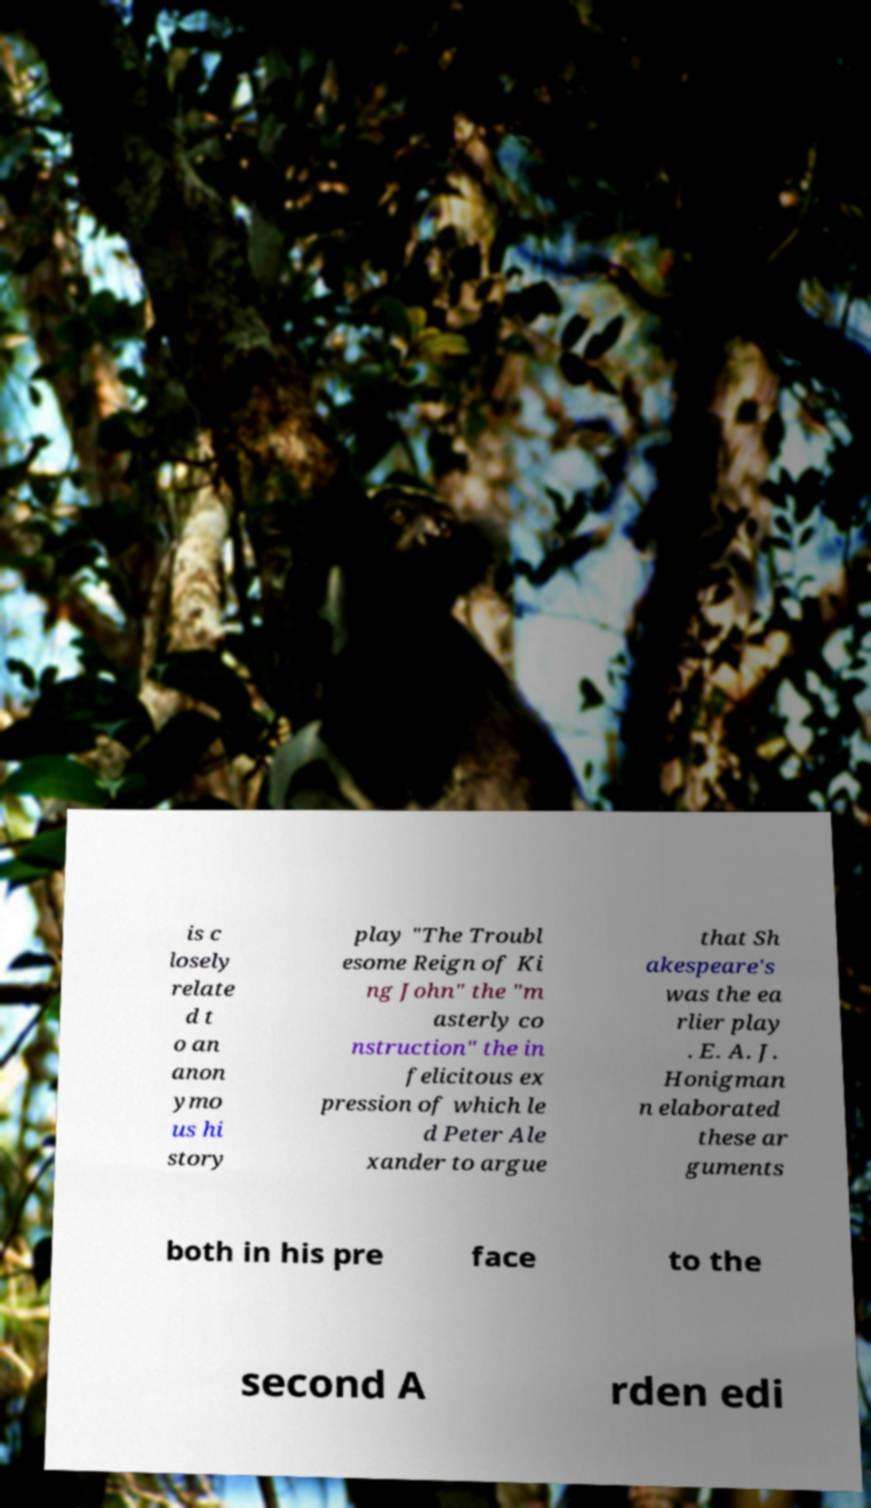Could you assist in decoding the text presented in this image and type it out clearly? is c losely relate d t o an anon ymo us hi story play "The Troubl esome Reign of Ki ng John" the "m asterly co nstruction" the in felicitous ex pression of which le d Peter Ale xander to argue that Sh akespeare's was the ea rlier play . E. A. J. Honigman n elaborated these ar guments both in his pre face to the second A rden edi 